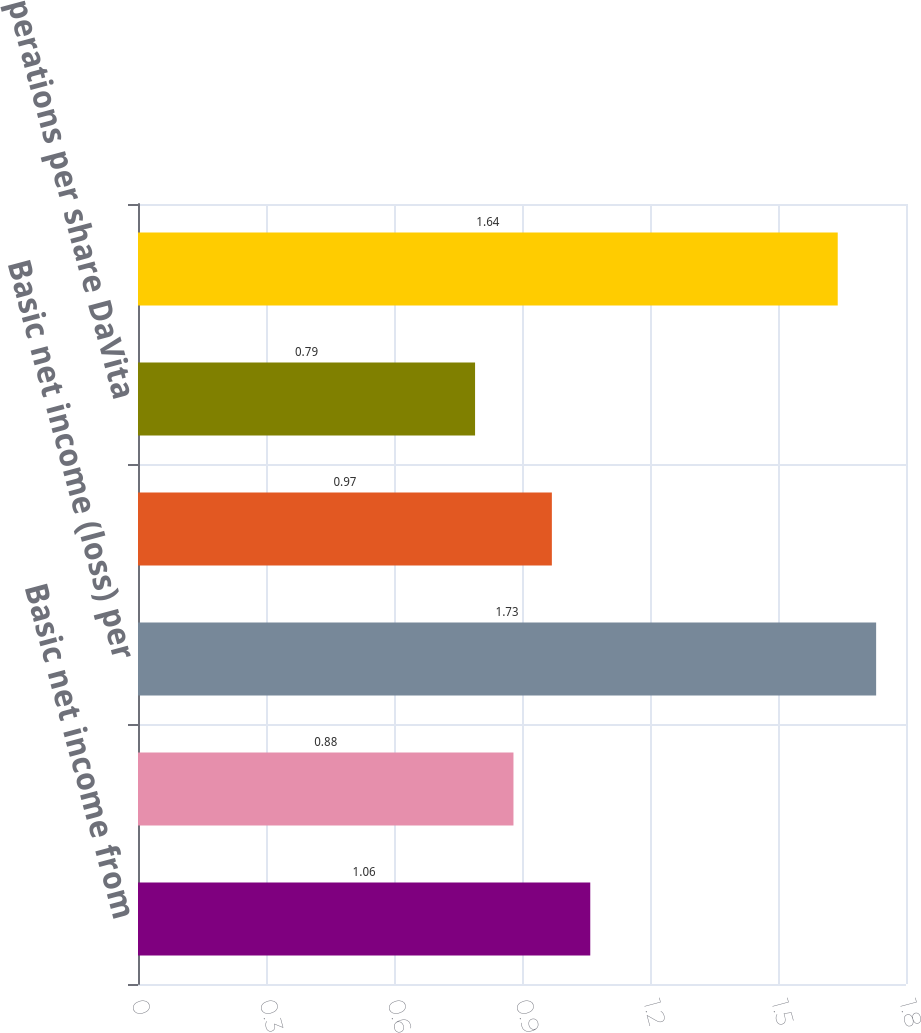<chart> <loc_0><loc_0><loc_500><loc_500><bar_chart><fcel>Basic net income from<fcel>Basic net income (loss) from<fcel>Basic net income (loss) per<fcel>from continuing operations per<fcel>operations per share DaVita<fcel>Diluted net income (loss) per<nl><fcel>1.06<fcel>0.88<fcel>1.73<fcel>0.97<fcel>0.79<fcel>1.64<nl></chart> 